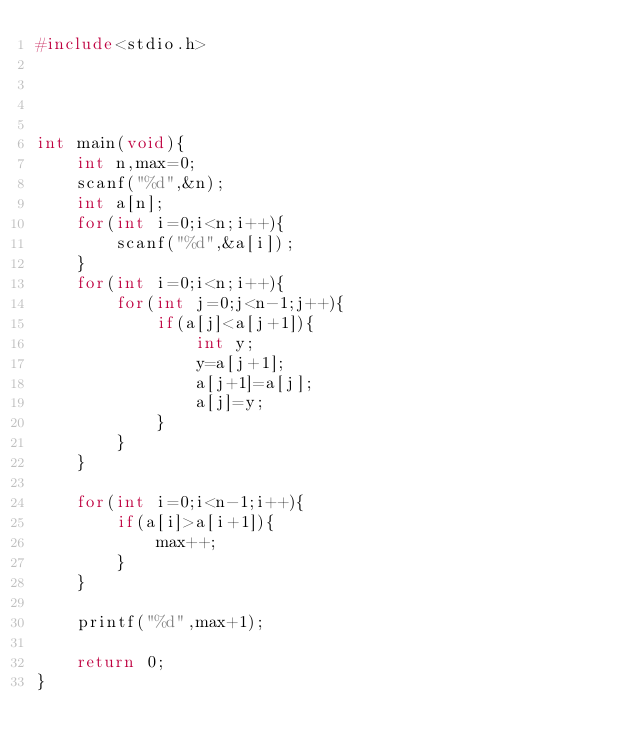<code> <loc_0><loc_0><loc_500><loc_500><_C_>#include<stdio.h>

 


int main(void){
    int n,max=0;
    scanf("%d",&n);
    int a[n];
    for(int i=0;i<n;i++){
        scanf("%d",&a[i]);   
    }
    for(int i=0;i<n;i++){
        for(int j=0;j<n-1;j++){
            if(a[j]<a[j+1]){
                int y;
                y=a[j+1];
                a[j+1]=a[j];
                a[j]=y;
            }
        }
    }

    for(int i=0;i<n-1;i++){
        if(a[i]>a[i+1]){
            max++;
        }
    }

    printf("%d",max+1);
    
    return 0;
}</code> 